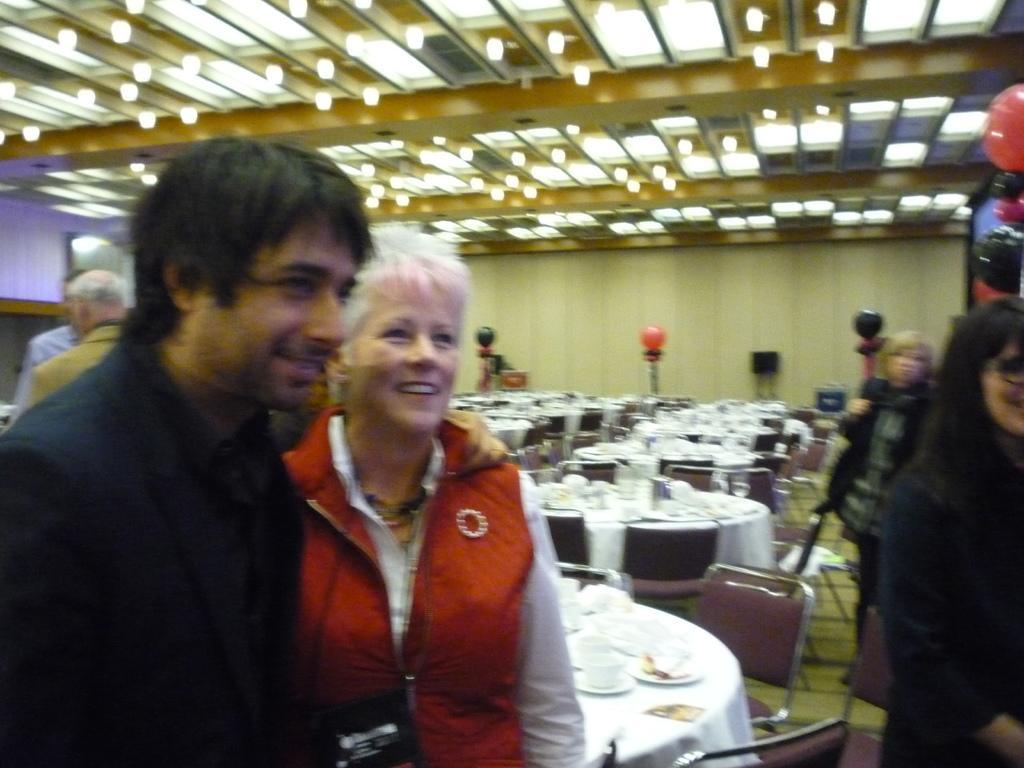Can you describe this image briefly? In this image there are people standing, in the background there are tables, on that tables there are few items, around the tables there are chairs, and there is a wall, at the top there is a ceiling and lights. 